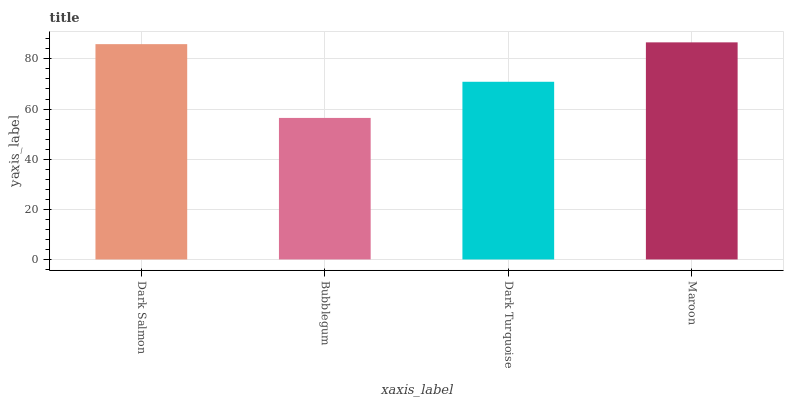Is Dark Turquoise the minimum?
Answer yes or no. No. Is Dark Turquoise the maximum?
Answer yes or no. No. Is Dark Turquoise greater than Bubblegum?
Answer yes or no. Yes. Is Bubblegum less than Dark Turquoise?
Answer yes or no. Yes. Is Bubblegum greater than Dark Turquoise?
Answer yes or no. No. Is Dark Turquoise less than Bubblegum?
Answer yes or no. No. Is Dark Salmon the high median?
Answer yes or no. Yes. Is Dark Turquoise the low median?
Answer yes or no. Yes. Is Maroon the high median?
Answer yes or no. No. Is Maroon the low median?
Answer yes or no. No. 